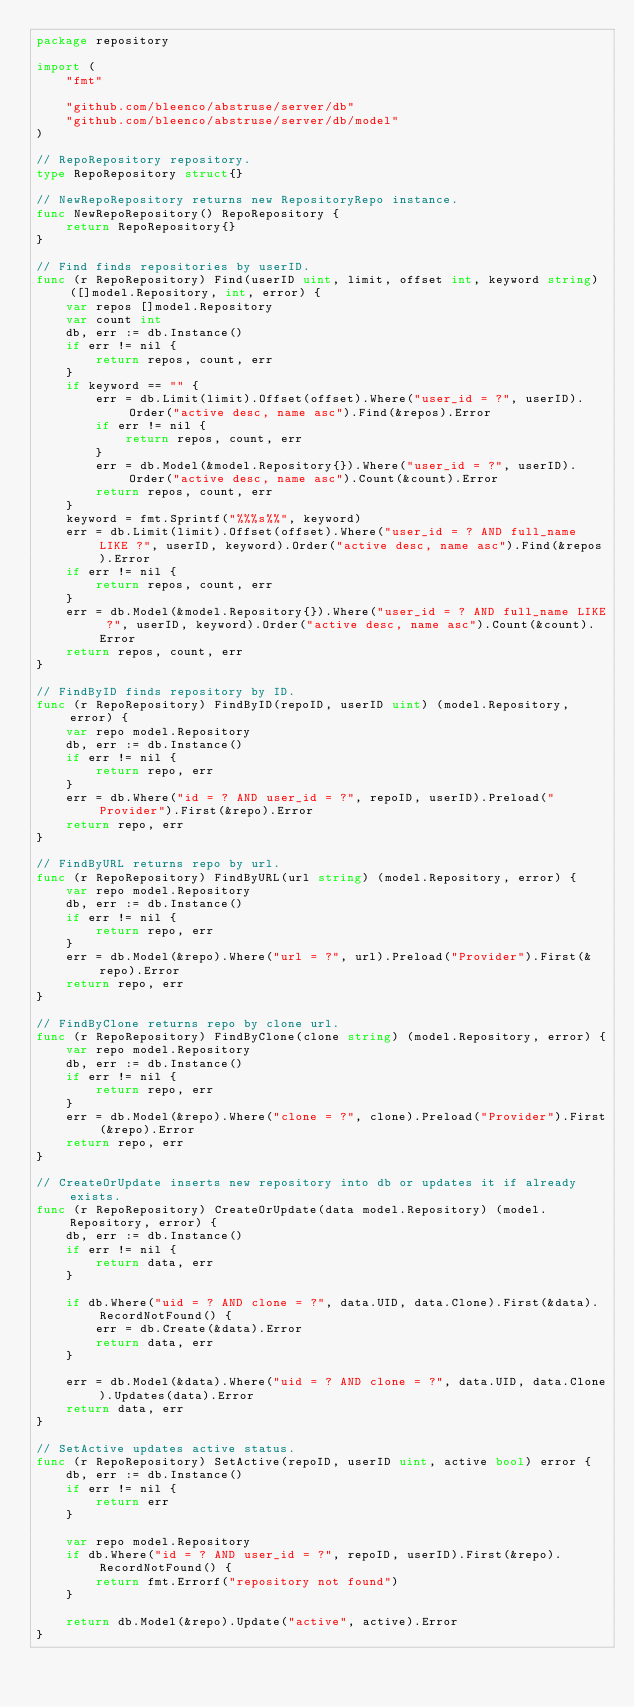Convert code to text. <code><loc_0><loc_0><loc_500><loc_500><_Go_>package repository

import (
	"fmt"

	"github.com/bleenco/abstruse/server/db"
	"github.com/bleenco/abstruse/server/db/model"
)

// RepoRepository repository.
type RepoRepository struct{}

// NewRepoRepository returns new RepositoryRepo instance.
func NewRepoRepository() RepoRepository {
	return RepoRepository{}
}

// Find finds repositories by userID.
func (r RepoRepository) Find(userID uint, limit, offset int, keyword string) ([]model.Repository, int, error) {
	var repos []model.Repository
	var count int
	db, err := db.Instance()
	if err != nil {
		return repos, count, err
	}
	if keyword == "" {
		err = db.Limit(limit).Offset(offset).Where("user_id = ?", userID).Order("active desc, name asc").Find(&repos).Error
		if err != nil {
			return repos, count, err
		}
		err = db.Model(&model.Repository{}).Where("user_id = ?", userID).Order("active desc, name asc").Count(&count).Error
		return repos, count, err
	}
	keyword = fmt.Sprintf("%%%s%%", keyword)
	err = db.Limit(limit).Offset(offset).Where("user_id = ? AND full_name LIKE ?", userID, keyword).Order("active desc, name asc").Find(&repos).Error
	if err != nil {
		return repos, count, err
	}
	err = db.Model(&model.Repository{}).Where("user_id = ? AND full_name LIKE ?", userID, keyword).Order("active desc, name asc").Count(&count).Error
	return repos, count, err
}

// FindByID finds repository by ID.
func (r RepoRepository) FindByID(repoID, userID uint) (model.Repository, error) {
	var repo model.Repository
	db, err := db.Instance()
	if err != nil {
		return repo, err
	}
	err = db.Where("id = ? AND user_id = ?", repoID, userID).Preload("Provider").First(&repo).Error
	return repo, err
}

// FindByURL returns repo by url.
func (r RepoRepository) FindByURL(url string) (model.Repository, error) {
	var repo model.Repository
	db, err := db.Instance()
	if err != nil {
		return repo, err
	}
	err = db.Model(&repo).Where("url = ?", url).Preload("Provider").First(&repo).Error
	return repo, err
}

// FindByClone returns repo by clone url.
func (r RepoRepository) FindByClone(clone string) (model.Repository, error) {
	var repo model.Repository
	db, err := db.Instance()
	if err != nil {
		return repo, err
	}
	err = db.Model(&repo).Where("clone = ?", clone).Preload("Provider").First(&repo).Error
	return repo, err
}

// CreateOrUpdate inserts new repository into db or updates it if already exists.
func (r RepoRepository) CreateOrUpdate(data model.Repository) (model.Repository, error) {
	db, err := db.Instance()
	if err != nil {
		return data, err
	}

	if db.Where("uid = ? AND clone = ?", data.UID, data.Clone).First(&data).RecordNotFound() {
		err = db.Create(&data).Error
		return data, err
	}

	err = db.Model(&data).Where("uid = ? AND clone = ?", data.UID, data.Clone).Updates(data).Error
	return data, err
}

// SetActive updates active status.
func (r RepoRepository) SetActive(repoID, userID uint, active bool) error {
	db, err := db.Instance()
	if err != nil {
		return err
	}

	var repo model.Repository
	if db.Where("id = ? AND user_id = ?", repoID, userID).First(&repo).RecordNotFound() {
		return fmt.Errorf("repository not found")
	}

	return db.Model(&repo).Update("active", active).Error
}
</code> 